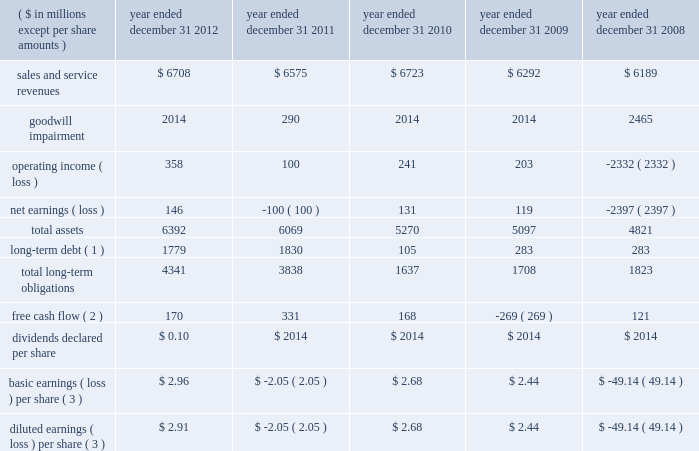Item 6 .
Selected financial data the table represents our selected financial data .
The table should be read in conjunction with item 7 and item 8 of this report .
The table below reflects immaterial error corrections discussed in note 2 : summary of significant accounting policies in item 8. .
Basic earnings ( loss ) per share ( 3 ) $ 2.96 $ ( 2.05 ) $ 2.68 $ 2.44 $ ( 49.14 ) diluted earnings ( loss ) per share ( 3 ) $ 2.91 $ ( 2.05 ) $ 2.68 $ 2.44 $ ( 49.14 ) ( 1 ) long-term debt does not include amounts payable to our former parent as of and before december 31 , 2010 , as these amounts were due upon demand and included in current liabilities .
( 2 ) free cash flow is a non-gaap financial measure and represents cash from operating activities less capital expenditures .
See liquidity and capital resources in item 7 for more information on this measure .
( 3 ) on march 30 , 2011 , the record date of the stock distribution associated with the spin-off from northrop grumman , approximately 48.8 million shares of $ 0.01 par value hii common stock were distributed to northrop grumman stockholders .
This share amount was utilized for the calculation of basic and diluted earnings ( loss ) per share for the three months ended march 31 , 2011 , and all prior periods , as no common stock of the company existed prior to march 30 , 2011 , and the impact of dilutive securities in the three month period ended march 31 , 2011 , was not meaningful. .
During 2010 , what was the return on assets? 
Rationale: net income divided by total assets
Computations: (131 / 5270)
Answer: 0.02486. 